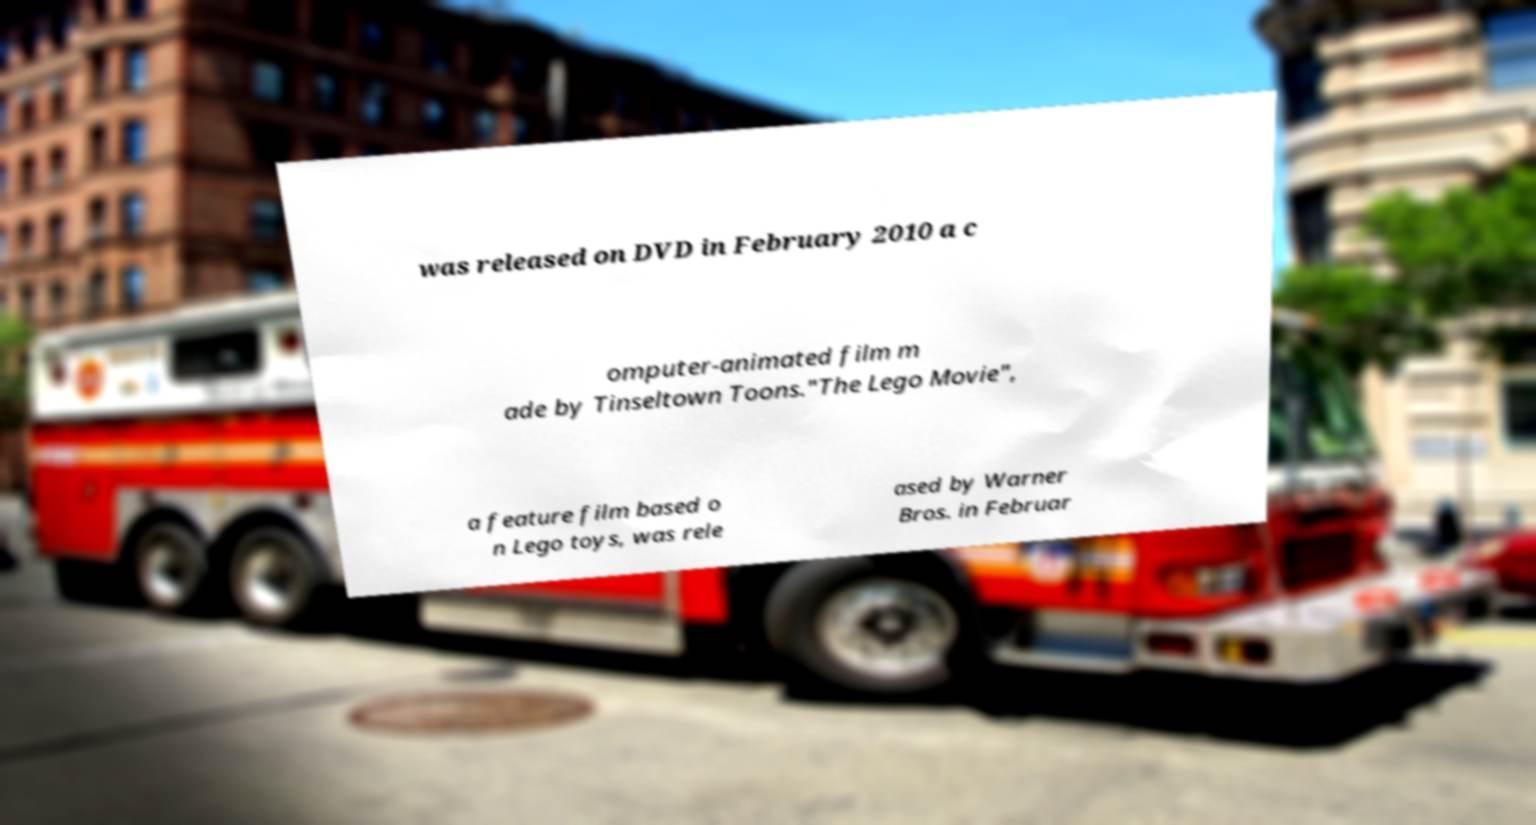Please read and relay the text visible in this image. What does it say? was released on DVD in February 2010 a c omputer-animated film m ade by Tinseltown Toons."The Lego Movie", a feature film based o n Lego toys, was rele ased by Warner Bros. in Februar 